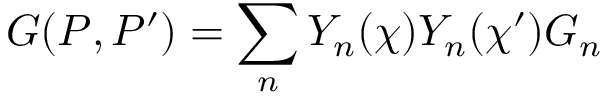<formula> <loc_0><loc_0><loc_500><loc_500>G ( P , P ^ { \prime } ) = \sum _ { n } Y _ { n } ( \chi ) Y _ { n } ( \chi ^ { \prime } ) G _ { n }</formula> 